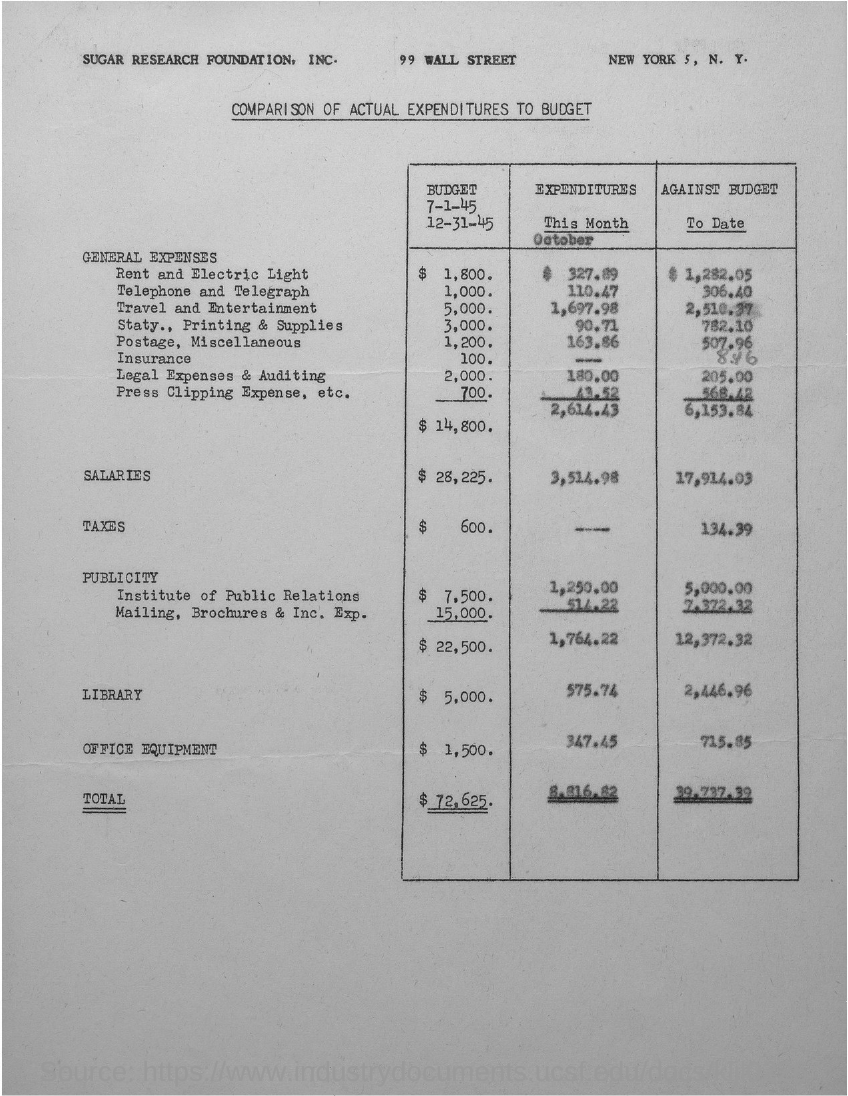What is the total expenditure?
Your answer should be very brief. 8,816.82. What is the actual salary?
Your answer should be very brief. 3,514.98. What is the actual expenditure for the library?
Offer a terse response. 575.74. What is the actual expenditure for the office equipment?
Provide a short and direct response. 347.45. 